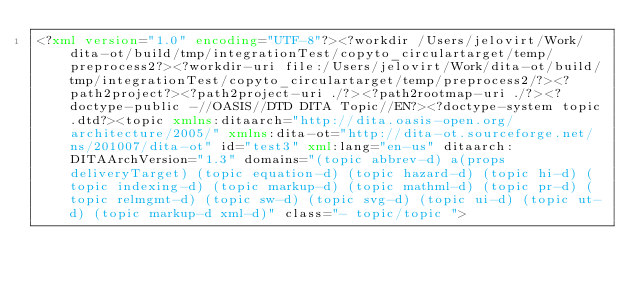<code> <loc_0><loc_0><loc_500><loc_500><_XML_><?xml version="1.0" encoding="UTF-8"?><?workdir /Users/jelovirt/Work/dita-ot/build/tmp/integrationTest/copyto_circulartarget/temp/preprocess2?><?workdir-uri file:/Users/jelovirt/Work/dita-ot/build/tmp/integrationTest/copyto_circulartarget/temp/preprocess2/?><?path2project?><?path2project-uri ./?><?path2rootmap-uri ./?><?doctype-public -//OASIS//DTD DITA Topic//EN?><?doctype-system topic.dtd?><topic xmlns:ditaarch="http://dita.oasis-open.org/architecture/2005/" xmlns:dita-ot="http://dita-ot.sourceforge.net/ns/201007/dita-ot" id="test3" xml:lang="en-us" ditaarch:DITAArchVersion="1.3" domains="(topic abbrev-d) a(props deliveryTarget) (topic equation-d) (topic hazard-d) (topic hi-d) (topic indexing-d) (topic markup-d) (topic mathml-d) (topic pr-d) (topic relmgmt-d) (topic sw-d) (topic svg-d) (topic ui-d) (topic ut-d) (topic markup-d xml-d)" class="- topic/topic "></code> 